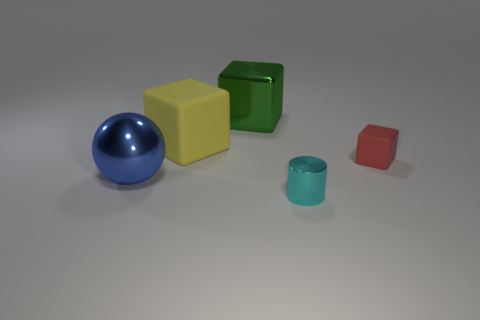Subtract all big rubber cubes. How many cubes are left? 2 Add 4 blue things. How many objects exist? 9 Subtract all yellow blocks. How many blocks are left? 2 Subtract all blocks. How many objects are left? 2 Subtract all blue blocks. Subtract all purple cylinders. How many blocks are left? 3 Add 5 tiny cubes. How many tiny cubes are left? 6 Add 5 tiny things. How many tiny things exist? 7 Subtract 0 blue blocks. How many objects are left? 5 Subtract all big green things. Subtract all cyan metallic things. How many objects are left? 3 